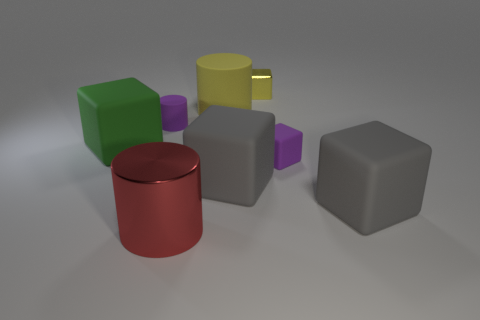How many gray cubes must be subtracted to get 1 gray cubes? 1 Subtract all purple cubes. How many cubes are left? 4 Subtract all green cubes. How many cubes are left? 4 Add 1 big yellow rubber spheres. How many objects exist? 9 Subtract all purple blocks. Subtract all red balls. How many blocks are left? 4 Subtract all cubes. How many objects are left? 3 Add 2 tiny objects. How many tiny objects are left? 5 Add 1 large rubber things. How many large rubber things exist? 5 Subtract 0 blue cylinders. How many objects are left? 8 Subtract all tiny cyan rubber cylinders. Subtract all large cubes. How many objects are left? 5 